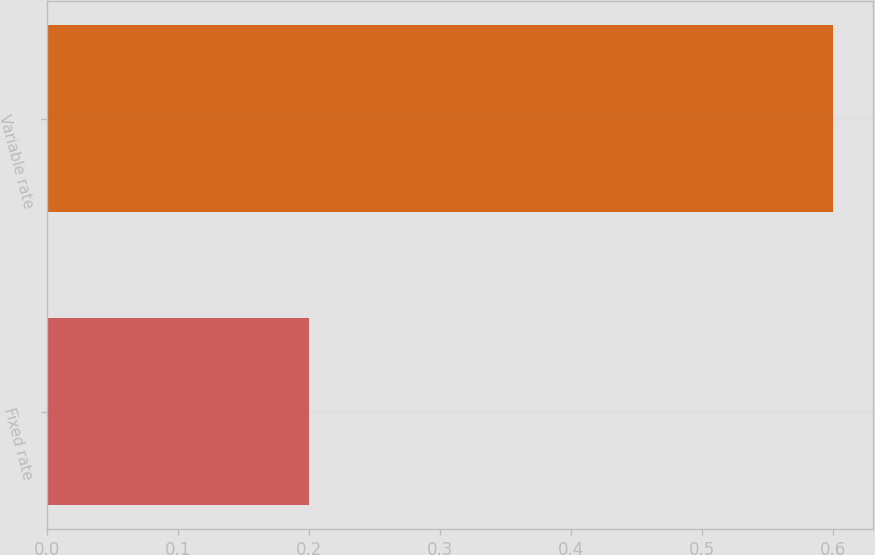Convert chart. <chart><loc_0><loc_0><loc_500><loc_500><bar_chart><fcel>Fixed rate<fcel>Variable rate<nl><fcel>0.2<fcel>0.6<nl></chart> 